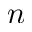Convert formula to latex. <formula><loc_0><loc_0><loc_500><loc_500>n</formula> 